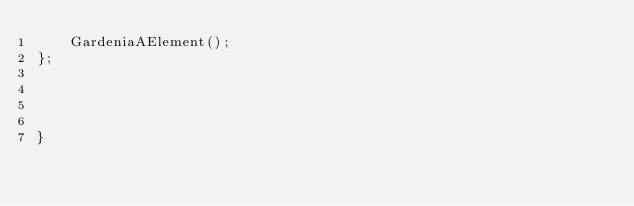<code> <loc_0><loc_0><loc_500><loc_500><_C++_>    GardeniaAElement();
};




}
</code> 